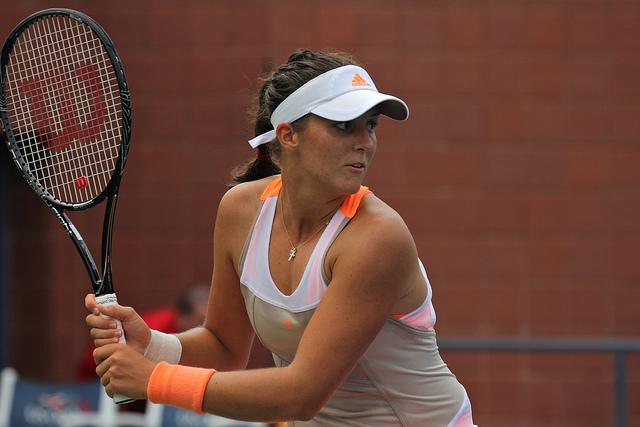Is the player right-handed?
Answer briefly. Yes. What kind of hat is the woman wearing?
Concise answer only. Visor. What color are the woman's eyes?
Write a very short answer. Brown. What brand is she sponsored by?
Concise answer only. Adidas. What brand is the woman's visor?
Write a very short answer. Adidas. Are there spectators?
Be succinct. No. What brand tennis racket is she using?
Short answer required. Wilson. Are there spectators in the scene?
Answer briefly. No. What game is she playing?
Give a very brief answer. Tennis. What is under the woman's eyes?
Concise answer only. Shadow. 